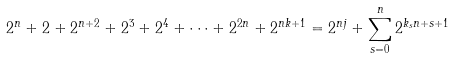<formula> <loc_0><loc_0><loc_500><loc_500>2 ^ { n } + 2 + 2 ^ { n + 2 } + 2 ^ { 3 } + 2 ^ { 4 } + \dots + 2 ^ { 2 n } + 2 ^ { n k + 1 } = 2 ^ { n j } + \sum _ { s = 0 } ^ { n } 2 ^ { k _ { s } n + s + 1 }</formula> 